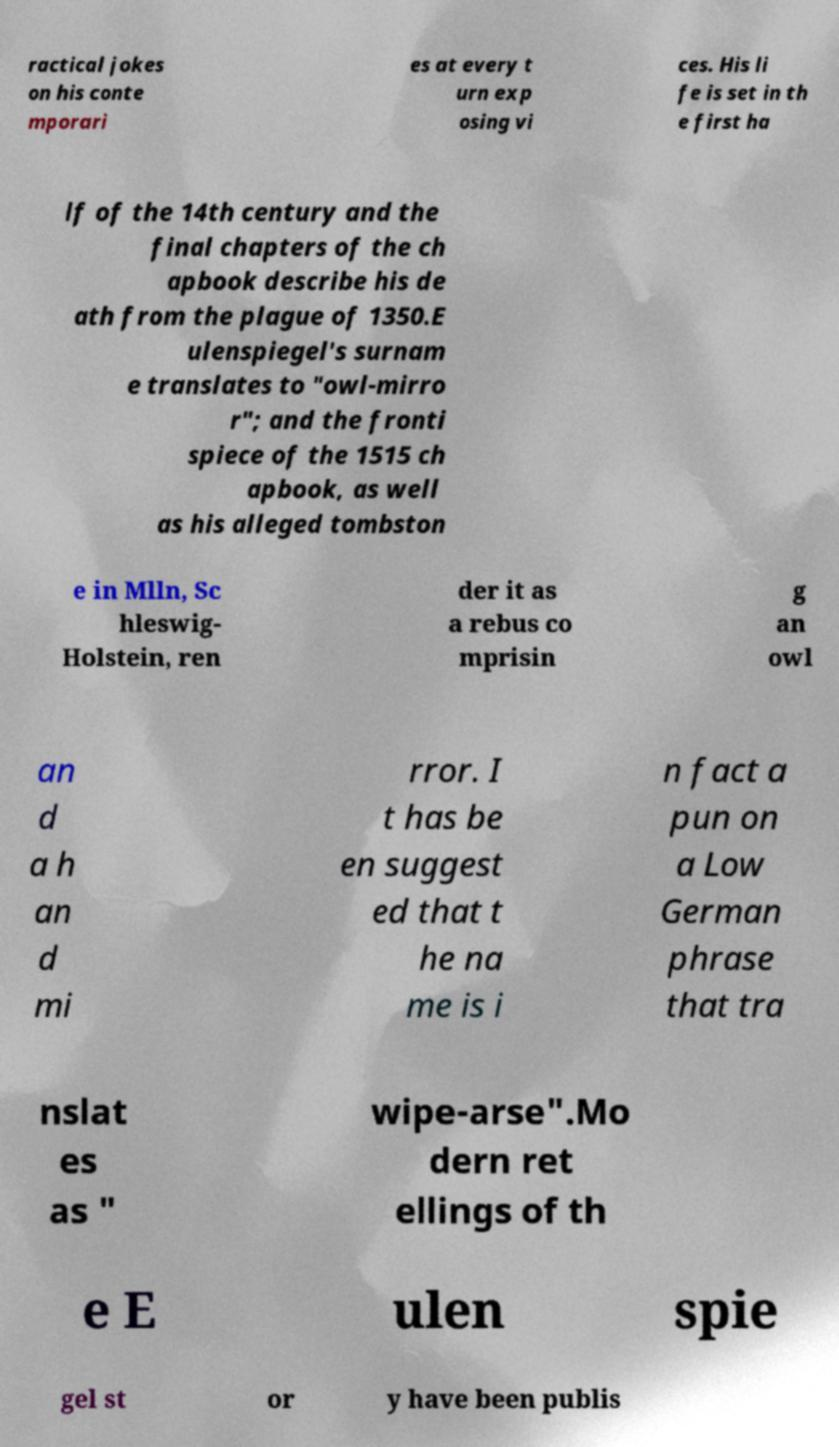I need the written content from this picture converted into text. Can you do that? ractical jokes on his conte mporari es at every t urn exp osing vi ces. His li fe is set in th e first ha lf of the 14th century and the final chapters of the ch apbook describe his de ath from the plague of 1350.E ulenspiegel's surnam e translates to "owl-mirro r"; and the fronti spiece of the 1515 ch apbook, as well as his alleged tombston e in Mlln, Sc hleswig- Holstein, ren der it as a rebus co mprisin g an owl an d a h an d mi rror. I t has be en suggest ed that t he na me is i n fact a pun on a Low German phrase that tra nslat es as " wipe-arse".Mo dern ret ellings of th e E ulen spie gel st or y have been publis 